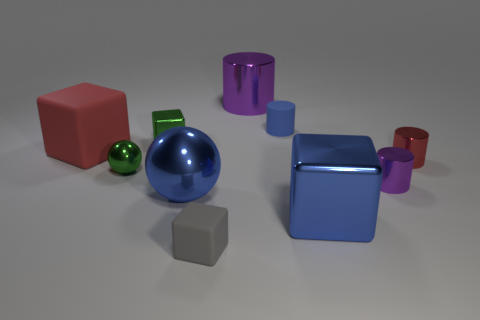What number of objects are big metal objects right of the blue cylinder or purple things that are in front of the big matte block?
Keep it short and to the point. 2. There is a red thing that is made of the same material as the blue cylinder; what size is it?
Offer a terse response. Large. Does the big shiny object to the right of the large purple metal cylinder have the same shape as the tiny blue rubber thing?
Provide a succinct answer. No. What size is the other cylinder that is the same color as the large cylinder?
Keep it short and to the point. Small. How many red objects are either big matte cubes or large things?
Provide a succinct answer. 1. How many other objects are the same shape as the big red object?
Provide a short and direct response. 3. There is a large object that is right of the green shiny ball and behind the tiny purple cylinder; what shape is it?
Ensure brevity in your answer.  Cylinder. Are there any big metal things left of the tiny metallic block?
Your answer should be very brief. No. There is a blue thing that is the same shape as the red rubber thing; what is its size?
Ensure brevity in your answer.  Large. Is there any other thing that is the same size as the blue cylinder?
Keep it short and to the point. Yes. 